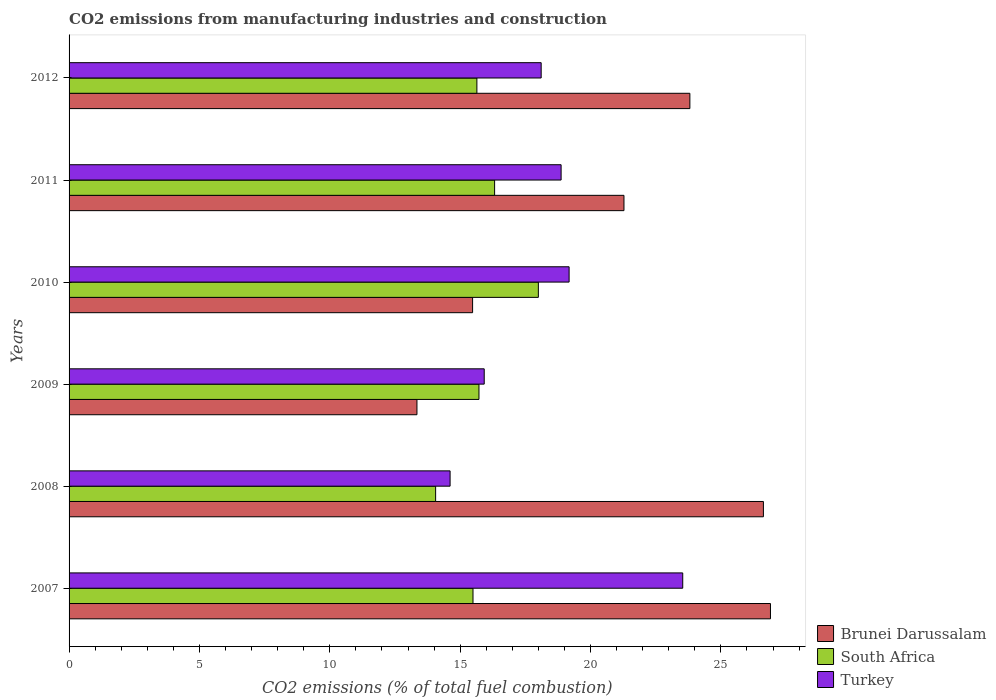How many different coloured bars are there?
Keep it short and to the point. 3. Are the number of bars per tick equal to the number of legend labels?
Keep it short and to the point. Yes. Are the number of bars on each tick of the Y-axis equal?
Give a very brief answer. Yes. How many bars are there on the 5th tick from the top?
Ensure brevity in your answer.  3. In how many cases, is the number of bars for a given year not equal to the number of legend labels?
Provide a short and direct response. 0. What is the amount of CO2 emitted in Brunei Darussalam in 2010?
Provide a succinct answer. 15.48. Across all years, what is the maximum amount of CO2 emitted in South Africa?
Provide a succinct answer. 18. Across all years, what is the minimum amount of CO2 emitted in Turkey?
Your answer should be compact. 14.61. In which year was the amount of CO2 emitted in South Africa minimum?
Your response must be concise. 2008. What is the total amount of CO2 emitted in Turkey in the graph?
Offer a very short reply. 110.23. What is the difference between the amount of CO2 emitted in Turkey in 2007 and that in 2011?
Your answer should be very brief. 4.66. What is the difference between the amount of CO2 emitted in South Africa in 2010 and the amount of CO2 emitted in Brunei Darussalam in 2012?
Offer a very short reply. -5.81. What is the average amount of CO2 emitted in South Africa per year?
Keep it short and to the point. 15.87. In the year 2012, what is the difference between the amount of CO2 emitted in Brunei Darussalam and amount of CO2 emitted in Turkey?
Ensure brevity in your answer.  5.7. What is the ratio of the amount of CO2 emitted in South Africa in 2007 to that in 2010?
Keep it short and to the point. 0.86. Is the amount of CO2 emitted in Brunei Darussalam in 2007 less than that in 2012?
Your answer should be compact. No. What is the difference between the highest and the second highest amount of CO2 emitted in South Africa?
Give a very brief answer. 1.68. What is the difference between the highest and the lowest amount of CO2 emitted in South Africa?
Your answer should be very brief. 3.94. In how many years, is the amount of CO2 emitted in South Africa greater than the average amount of CO2 emitted in South Africa taken over all years?
Your answer should be very brief. 2. Is the sum of the amount of CO2 emitted in Brunei Darussalam in 2010 and 2012 greater than the maximum amount of CO2 emitted in Turkey across all years?
Offer a very short reply. Yes. What does the 1st bar from the top in 2008 represents?
Keep it short and to the point. Turkey. How many bars are there?
Provide a short and direct response. 18. What is the difference between two consecutive major ticks on the X-axis?
Your answer should be compact. 5. Are the values on the major ticks of X-axis written in scientific E-notation?
Your answer should be very brief. No. Does the graph contain any zero values?
Offer a very short reply. No. How many legend labels are there?
Provide a short and direct response. 3. How are the legend labels stacked?
Your response must be concise. Vertical. What is the title of the graph?
Give a very brief answer. CO2 emissions from manufacturing industries and construction. Does "Brazil" appear as one of the legend labels in the graph?
Provide a short and direct response. No. What is the label or title of the X-axis?
Provide a succinct answer. CO2 emissions (% of total fuel combustion). What is the label or title of the Y-axis?
Your answer should be compact. Years. What is the CO2 emissions (% of total fuel combustion) in Brunei Darussalam in 2007?
Make the answer very short. 26.9. What is the CO2 emissions (% of total fuel combustion) in South Africa in 2007?
Keep it short and to the point. 15.49. What is the CO2 emissions (% of total fuel combustion) in Turkey in 2007?
Your response must be concise. 23.54. What is the CO2 emissions (% of total fuel combustion) of Brunei Darussalam in 2008?
Make the answer very short. 26.63. What is the CO2 emissions (% of total fuel combustion) of South Africa in 2008?
Your response must be concise. 14.06. What is the CO2 emissions (% of total fuel combustion) in Turkey in 2008?
Keep it short and to the point. 14.61. What is the CO2 emissions (% of total fuel combustion) in Brunei Darussalam in 2009?
Provide a succinct answer. 13.34. What is the CO2 emissions (% of total fuel combustion) of South Africa in 2009?
Offer a terse response. 15.72. What is the CO2 emissions (% of total fuel combustion) of Turkey in 2009?
Your answer should be very brief. 15.92. What is the CO2 emissions (% of total fuel combustion) in Brunei Darussalam in 2010?
Keep it short and to the point. 15.48. What is the CO2 emissions (% of total fuel combustion) of South Africa in 2010?
Keep it short and to the point. 18. What is the CO2 emissions (% of total fuel combustion) in Turkey in 2010?
Your response must be concise. 19.18. What is the CO2 emissions (% of total fuel combustion) in Brunei Darussalam in 2011?
Offer a very short reply. 21.28. What is the CO2 emissions (% of total fuel combustion) in South Africa in 2011?
Give a very brief answer. 16.32. What is the CO2 emissions (% of total fuel combustion) of Turkey in 2011?
Offer a terse response. 18.87. What is the CO2 emissions (% of total fuel combustion) in Brunei Darussalam in 2012?
Ensure brevity in your answer.  23.81. What is the CO2 emissions (% of total fuel combustion) in South Africa in 2012?
Your response must be concise. 15.64. What is the CO2 emissions (% of total fuel combustion) of Turkey in 2012?
Offer a very short reply. 18.11. Across all years, what is the maximum CO2 emissions (% of total fuel combustion) in Brunei Darussalam?
Provide a succinct answer. 26.9. Across all years, what is the maximum CO2 emissions (% of total fuel combustion) in South Africa?
Offer a very short reply. 18. Across all years, what is the maximum CO2 emissions (% of total fuel combustion) of Turkey?
Provide a short and direct response. 23.54. Across all years, what is the minimum CO2 emissions (% of total fuel combustion) of Brunei Darussalam?
Your answer should be very brief. 13.34. Across all years, what is the minimum CO2 emissions (% of total fuel combustion) in South Africa?
Provide a succinct answer. 14.06. Across all years, what is the minimum CO2 emissions (% of total fuel combustion) of Turkey?
Provide a succinct answer. 14.61. What is the total CO2 emissions (% of total fuel combustion) of Brunei Darussalam in the graph?
Provide a short and direct response. 127.44. What is the total CO2 emissions (% of total fuel combustion) of South Africa in the graph?
Ensure brevity in your answer.  95.23. What is the total CO2 emissions (% of total fuel combustion) of Turkey in the graph?
Give a very brief answer. 110.23. What is the difference between the CO2 emissions (% of total fuel combustion) in Brunei Darussalam in 2007 and that in 2008?
Make the answer very short. 0.27. What is the difference between the CO2 emissions (% of total fuel combustion) in South Africa in 2007 and that in 2008?
Ensure brevity in your answer.  1.43. What is the difference between the CO2 emissions (% of total fuel combustion) in Turkey in 2007 and that in 2008?
Offer a terse response. 8.92. What is the difference between the CO2 emissions (% of total fuel combustion) of Brunei Darussalam in 2007 and that in 2009?
Your answer should be very brief. 13.56. What is the difference between the CO2 emissions (% of total fuel combustion) of South Africa in 2007 and that in 2009?
Offer a terse response. -0.23. What is the difference between the CO2 emissions (% of total fuel combustion) of Turkey in 2007 and that in 2009?
Give a very brief answer. 7.61. What is the difference between the CO2 emissions (% of total fuel combustion) of Brunei Darussalam in 2007 and that in 2010?
Give a very brief answer. 11.42. What is the difference between the CO2 emissions (% of total fuel combustion) of South Africa in 2007 and that in 2010?
Provide a succinct answer. -2.51. What is the difference between the CO2 emissions (% of total fuel combustion) of Turkey in 2007 and that in 2010?
Your answer should be compact. 4.36. What is the difference between the CO2 emissions (% of total fuel combustion) of Brunei Darussalam in 2007 and that in 2011?
Your answer should be compact. 5.62. What is the difference between the CO2 emissions (% of total fuel combustion) of South Africa in 2007 and that in 2011?
Your answer should be very brief. -0.83. What is the difference between the CO2 emissions (% of total fuel combustion) of Turkey in 2007 and that in 2011?
Your answer should be very brief. 4.66. What is the difference between the CO2 emissions (% of total fuel combustion) in Brunei Darussalam in 2007 and that in 2012?
Provide a succinct answer. 3.09. What is the difference between the CO2 emissions (% of total fuel combustion) of South Africa in 2007 and that in 2012?
Provide a succinct answer. -0.15. What is the difference between the CO2 emissions (% of total fuel combustion) of Turkey in 2007 and that in 2012?
Give a very brief answer. 5.43. What is the difference between the CO2 emissions (% of total fuel combustion) of Brunei Darussalam in 2008 and that in 2009?
Your answer should be compact. 13.29. What is the difference between the CO2 emissions (% of total fuel combustion) in South Africa in 2008 and that in 2009?
Your answer should be compact. -1.66. What is the difference between the CO2 emissions (% of total fuel combustion) in Turkey in 2008 and that in 2009?
Provide a succinct answer. -1.31. What is the difference between the CO2 emissions (% of total fuel combustion) in Brunei Darussalam in 2008 and that in 2010?
Keep it short and to the point. 11.15. What is the difference between the CO2 emissions (% of total fuel combustion) of South Africa in 2008 and that in 2010?
Your response must be concise. -3.94. What is the difference between the CO2 emissions (% of total fuel combustion) in Turkey in 2008 and that in 2010?
Provide a short and direct response. -4.56. What is the difference between the CO2 emissions (% of total fuel combustion) in Brunei Darussalam in 2008 and that in 2011?
Your answer should be very brief. 5.35. What is the difference between the CO2 emissions (% of total fuel combustion) of South Africa in 2008 and that in 2011?
Keep it short and to the point. -2.26. What is the difference between the CO2 emissions (% of total fuel combustion) in Turkey in 2008 and that in 2011?
Provide a succinct answer. -4.26. What is the difference between the CO2 emissions (% of total fuel combustion) of Brunei Darussalam in 2008 and that in 2012?
Your answer should be compact. 2.82. What is the difference between the CO2 emissions (% of total fuel combustion) in South Africa in 2008 and that in 2012?
Your answer should be very brief. -1.58. What is the difference between the CO2 emissions (% of total fuel combustion) of Turkey in 2008 and that in 2012?
Offer a very short reply. -3.49. What is the difference between the CO2 emissions (% of total fuel combustion) of Brunei Darussalam in 2009 and that in 2010?
Make the answer very short. -2.13. What is the difference between the CO2 emissions (% of total fuel combustion) of South Africa in 2009 and that in 2010?
Your answer should be compact. -2.28. What is the difference between the CO2 emissions (% of total fuel combustion) in Turkey in 2009 and that in 2010?
Your response must be concise. -3.26. What is the difference between the CO2 emissions (% of total fuel combustion) of Brunei Darussalam in 2009 and that in 2011?
Your response must be concise. -7.94. What is the difference between the CO2 emissions (% of total fuel combustion) in South Africa in 2009 and that in 2011?
Give a very brief answer. -0.6. What is the difference between the CO2 emissions (% of total fuel combustion) of Turkey in 2009 and that in 2011?
Provide a short and direct response. -2.95. What is the difference between the CO2 emissions (% of total fuel combustion) in Brunei Darussalam in 2009 and that in 2012?
Ensure brevity in your answer.  -10.47. What is the difference between the CO2 emissions (% of total fuel combustion) in South Africa in 2009 and that in 2012?
Provide a succinct answer. 0.08. What is the difference between the CO2 emissions (% of total fuel combustion) of Turkey in 2009 and that in 2012?
Give a very brief answer. -2.18. What is the difference between the CO2 emissions (% of total fuel combustion) of Brunei Darussalam in 2010 and that in 2011?
Give a very brief answer. -5.81. What is the difference between the CO2 emissions (% of total fuel combustion) in South Africa in 2010 and that in 2011?
Your answer should be very brief. 1.68. What is the difference between the CO2 emissions (% of total fuel combustion) in Turkey in 2010 and that in 2011?
Ensure brevity in your answer.  0.31. What is the difference between the CO2 emissions (% of total fuel combustion) in Brunei Darussalam in 2010 and that in 2012?
Ensure brevity in your answer.  -8.33. What is the difference between the CO2 emissions (% of total fuel combustion) in South Africa in 2010 and that in 2012?
Ensure brevity in your answer.  2.36. What is the difference between the CO2 emissions (% of total fuel combustion) in Turkey in 2010 and that in 2012?
Provide a succinct answer. 1.07. What is the difference between the CO2 emissions (% of total fuel combustion) in Brunei Darussalam in 2011 and that in 2012?
Provide a succinct answer. -2.53. What is the difference between the CO2 emissions (% of total fuel combustion) in South Africa in 2011 and that in 2012?
Offer a very short reply. 0.68. What is the difference between the CO2 emissions (% of total fuel combustion) of Turkey in 2011 and that in 2012?
Your answer should be compact. 0.76. What is the difference between the CO2 emissions (% of total fuel combustion) in Brunei Darussalam in 2007 and the CO2 emissions (% of total fuel combustion) in South Africa in 2008?
Provide a short and direct response. 12.84. What is the difference between the CO2 emissions (% of total fuel combustion) of Brunei Darussalam in 2007 and the CO2 emissions (% of total fuel combustion) of Turkey in 2008?
Give a very brief answer. 12.29. What is the difference between the CO2 emissions (% of total fuel combustion) of South Africa in 2007 and the CO2 emissions (% of total fuel combustion) of Turkey in 2008?
Offer a very short reply. 0.88. What is the difference between the CO2 emissions (% of total fuel combustion) of Brunei Darussalam in 2007 and the CO2 emissions (% of total fuel combustion) of South Africa in 2009?
Make the answer very short. 11.18. What is the difference between the CO2 emissions (% of total fuel combustion) in Brunei Darussalam in 2007 and the CO2 emissions (% of total fuel combustion) in Turkey in 2009?
Keep it short and to the point. 10.98. What is the difference between the CO2 emissions (% of total fuel combustion) in South Africa in 2007 and the CO2 emissions (% of total fuel combustion) in Turkey in 2009?
Provide a succinct answer. -0.43. What is the difference between the CO2 emissions (% of total fuel combustion) of Brunei Darussalam in 2007 and the CO2 emissions (% of total fuel combustion) of South Africa in 2010?
Offer a terse response. 8.9. What is the difference between the CO2 emissions (% of total fuel combustion) in Brunei Darussalam in 2007 and the CO2 emissions (% of total fuel combustion) in Turkey in 2010?
Ensure brevity in your answer.  7.72. What is the difference between the CO2 emissions (% of total fuel combustion) in South Africa in 2007 and the CO2 emissions (% of total fuel combustion) in Turkey in 2010?
Your response must be concise. -3.69. What is the difference between the CO2 emissions (% of total fuel combustion) of Brunei Darussalam in 2007 and the CO2 emissions (% of total fuel combustion) of South Africa in 2011?
Provide a succinct answer. 10.58. What is the difference between the CO2 emissions (% of total fuel combustion) of Brunei Darussalam in 2007 and the CO2 emissions (% of total fuel combustion) of Turkey in 2011?
Provide a succinct answer. 8.03. What is the difference between the CO2 emissions (% of total fuel combustion) in South Africa in 2007 and the CO2 emissions (% of total fuel combustion) in Turkey in 2011?
Provide a succinct answer. -3.38. What is the difference between the CO2 emissions (% of total fuel combustion) of Brunei Darussalam in 2007 and the CO2 emissions (% of total fuel combustion) of South Africa in 2012?
Offer a terse response. 11.26. What is the difference between the CO2 emissions (% of total fuel combustion) of Brunei Darussalam in 2007 and the CO2 emissions (% of total fuel combustion) of Turkey in 2012?
Your answer should be compact. 8.79. What is the difference between the CO2 emissions (% of total fuel combustion) in South Africa in 2007 and the CO2 emissions (% of total fuel combustion) in Turkey in 2012?
Your answer should be very brief. -2.61. What is the difference between the CO2 emissions (% of total fuel combustion) in Brunei Darussalam in 2008 and the CO2 emissions (% of total fuel combustion) in South Africa in 2009?
Provide a succinct answer. 10.91. What is the difference between the CO2 emissions (% of total fuel combustion) in Brunei Darussalam in 2008 and the CO2 emissions (% of total fuel combustion) in Turkey in 2009?
Provide a short and direct response. 10.71. What is the difference between the CO2 emissions (% of total fuel combustion) of South Africa in 2008 and the CO2 emissions (% of total fuel combustion) of Turkey in 2009?
Provide a succinct answer. -1.86. What is the difference between the CO2 emissions (% of total fuel combustion) of Brunei Darussalam in 2008 and the CO2 emissions (% of total fuel combustion) of South Africa in 2010?
Offer a very short reply. 8.63. What is the difference between the CO2 emissions (% of total fuel combustion) in Brunei Darussalam in 2008 and the CO2 emissions (% of total fuel combustion) in Turkey in 2010?
Make the answer very short. 7.45. What is the difference between the CO2 emissions (% of total fuel combustion) in South Africa in 2008 and the CO2 emissions (% of total fuel combustion) in Turkey in 2010?
Your response must be concise. -5.12. What is the difference between the CO2 emissions (% of total fuel combustion) of Brunei Darussalam in 2008 and the CO2 emissions (% of total fuel combustion) of South Africa in 2011?
Offer a terse response. 10.31. What is the difference between the CO2 emissions (% of total fuel combustion) of Brunei Darussalam in 2008 and the CO2 emissions (% of total fuel combustion) of Turkey in 2011?
Your answer should be very brief. 7.76. What is the difference between the CO2 emissions (% of total fuel combustion) of South Africa in 2008 and the CO2 emissions (% of total fuel combustion) of Turkey in 2011?
Provide a short and direct response. -4.81. What is the difference between the CO2 emissions (% of total fuel combustion) in Brunei Darussalam in 2008 and the CO2 emissions (% of total fuel combustion) in South Africa in 2012?
Offer a terse response. 10.99. What is the difference between the CO2 emissions (% of total fuel combustion) of Brunei Darussalam in 2008 and the CO2 emissions (% of total fuel combustion) of Turkey in 2012?
Make the answer very short. 8.52. What is the difference between the CO2 emissions (% of total fuel combustion) in South Africa in 2008 and the CO2 emissions (% of total fuel combustion) in Turkey in 2012?
Provide a short and direct response. -4.05. What is the difference between the CO2 emissions (% of total fuel combustion) of Brunei Darussalam in 2009 and the CO2 emissions (% of total fuel combustion) of South Africa in 2010?
Offer a very short reply. -4.66. What is the difference between the CO2 emissions (% of total fuel combustion) in Brunei Darussalam in 2009 and the CO2 emissions (% of total fuel combustion) in Turkey in 2010?
Your answer should be compact. -5.84. What is the difference between the CO2 emissions (% of total fuel combustion) of South Africa in 2009 and the CO2 emissions (% of total fuel combustion) of Turkey in 2010?
Your answer should be compact. -3.46. What is the difference between the CO2 emissions (% of total fuel combustion) of Brunei Darussalam in 2009 and the CO2 emissions (% of total fuel combustion) of South Africa in 2011?
Your answer should be compact. -2.98. What is the difference between the CO2 emissions (% of total fuel combustion) of Brunei Darussalam in 2009 and the CO2 emissions (% of total fuel combustion) of Turkey in 2011?
Your answer should be compact. -5.53. What is the difference between the CO2 emissions (% of total fuel combustion) of South Africa in 2009 and the CO2 emissions (% of total fuel combustion) of Turkey in 2011?
Make the answer very short. -3.15. What is the difference between the CO2 emissions (% of total fuel combustion) of Brunei Darussalam in 2009 and the CO2 emissions (% of total fuel combustion) of South Africa in 2012?
Provide a short and direct response. -2.3. What is the difference between the CO2 emissions (% of total fuel combustion) of Brunei Darussalam in 2009 and the CO2 emissions (% of total fuel combustion) of Turkey in 2012?
Ensure brevity in your answer.  -4.76. What is the difference between the CO2 emissions (% of total fuel combustion) in South Africa in 2009 and the CO2 emissions (% of total fuel combustion) in Turkey in 2012?
Keep it short and to the point. -2.39. What is the difference between the CO2 emissions (% of total fuel combustion) in Brunei Darussalam in 2010 and the CO2 emissions (% of total fuel combustion) in South Africa in 2011?
Provide a succinct answer. -0.84. What is the difference between the CO2 emissions (% of total fuel combustion) of Brunei Darussalam in 2010 and the CO2 emissions (% of total fuel combustion) of Turkey in 2011?
Ensure brevity in your answer.  -3.39. What is the difference between the CO2 emissions (% of total fuel combustion) of South Africa in 2010 and the CO2 emissions (% of total fuel combustion) of Turkey in 2011?
Offer a terse response. -0.87. What is the difference between the CO2 emissions (% of total fuel combustion) of Brunei Darussalam in 2010 and the CO2 emissions (% of total fuel combustion) of South Africa in 2012?
Make the answer very short. -0.17. What is the difference between the CO2 emissions (% of total fuel combustion) in Brunei Darussalam in 2010 and the CO2 emissions (% of total fuel combustion) in Turkey in 2012?
Offer a terse response. -2.63. What is the difference between the CO2 emissions (% of total fuel combustion) of South Africa in 2010 and the CO2 emissions (% of total fuel combustion) of Turkey in 2012?
Give a very brief answer. -0.11. What is the difference between the CO2 emissions (% of total fuel combustion) in Brunei Darussalam in 2011 and the CO2 emissions (% of total fuel combustion) in South Africa in 2012?
Offer a terse response. 5.64. What is the difference between the CO2 emissions (% of total fuel combustion) in Brunei Darussalam in 2011 and the CO2 emissions (% of total fuel combustion) in Turkey in 2012?
Offer a terse response. 3.18. What is the difference between the CO2 emissions (% of total fuel combustion) of South Africa in 2011 and the CO2 emissions (% of total fuel combustion) of Turkey in 2012?
Your answer should be compact. -1.79. What is the average CO2 emissions (% of total fuel combustion) in Brunei Darussalam per year?
Give a very brief answer. 21.24. What is the average CO2 emissions (% of total fuel combustion) in South Africa per year?
Provide a succinct answer. 15.87. What is the average CO2 emissions (% of total fuel combustion) of Turkey per year?
Your answer should be compact. 18.37. In the year 2007, what is the difference between the CO2 emissions (% of total fuel combustion) in Brunei Darussalam and CO2 emissions (% of total fuel combustion) in South Africa?
Offer a very short reply. 11.41. In the year 2007, what is the difference between the CO2 emissions (% of total fuel combustion) of Brunei Darussalam and CO2 emissions (% of total fuel combustion) of Turkey?
Offer a terse response. 3.36. In the year 2007, what is the difference between the CO2 emissions (% of total fuel combustion) in South Africa and CO2 emissions (% of total fuel combustion) in Turkey?
Your response must be concise. -8.04. In the year 2008, what is the difference between the CO2 emissions (% of total fuel combustion) of Brunei Darussalam and CO2 emissions (% of total fuel combustion) of South Africa?
Provide a succinct answer. 12.57. In the year 2008, what is the difference between the CO2 emissions (% of total fuel combustion) of Brunei Darussalam and CO2 emissions (% of total fuel combustion) of Turkey?
Offer a terse response. 12.02. In the year 2008, what is the difference between the CO2 emissions (% of total fuel combustion) in South Africa and CO2 emissions (% of total fuel combustion) in Turkey?
Offer a very short reply. -0.55. In the year 2009, what is the difference between the CO2 emissions (% of total fuel combustion) of Brunei Darussalam and CO2 emissions (% of total fuel combustion) of South Africa?
Keep it short and to the point. -2.38. In the year 2009, what is the difference between the CO2 emissions (% of total fuel combustion) in Brunei Darussalam and CO2 emissions (% of total fuel combustion) in Turkey?
Provide a short and direct response. -2.58. In the year 2009, what is the difference between the CO2 emissions (% of total fuel combustion) in South Africa and CO2 emissions (% of total fuel combustion) in Turkey?
Ensure brevity in your answer.  -0.2. In the year 2010, what is the difference between the CO2 emissions (% of total fuel combustion) of Brunei Darussalam and CO2 emissions (% of total fuel combustion) of South Africa?
Make the answer very short. -2.52. In the year 2010, what is the difference between the CO2 emissions (% of total fuel combustion) in Brunei Darussalam and CO2 emissions (% of total fuel combustion) in Turkey?
Your answer should be very brief. -3.7. In the year 2010, what is the difference between the CO2 emissions (% of total fuel combustion) of South Africa and CO2 emissions (% of total fuel combustion) of Turkey?
Provide a succinct answer. -1.18. In the year 2011, what is the difference between the CO2 emissions (% of total fuel combustion) of Brunei Darussalam and CO2 emissions (% of total fuel combustion) of South Africa?
Provide a succinct answer. 4.96. In the year 2011, what is the difference between the CO2 emissions (% of total fuel combustion) of Brunei Darussalam and CO2 emissions (% of total fuel combustion) of Turkey?
Offer a very short reply. 2.41. In the year 2011, what is the difference between the CO2 emissions (% of total fuel combustion) in South Africa and CO2 emissions (% of total fuel combustion) in Turkey?
Keep it short and to the point. -2.55. In the year 2012, what is the difference between the CO2 emissions (% of total fuel combustion) in Brunei Darussalam and CO2 emissions (% of total fuel combustion) in South Africa?
Provide a short and direct response. 8.17. In the year 2012, what is the difference between the CO2 emissions (% of total fuel combustion) in Brunei Darussalam and CO2 emissions (% of total fuel combustion) in Turkey?
Offer a very short reply. 5.7. In the year 2012, what is the difference between the CO2 emissions (% of total fuel combustion) of South Africa and CO2 emissions (% of total fuel combustion) of Turkey?
Offer a terse response. -2.47. What is the ratio of the CO2 emissions (% of total fuel combustion) of Brunei Darussalam in 2007 to that in 2008?
Your response must be concise. 1.01. What is the ratio of the CO2 emissions (% of total fuel combustion) in South Africa in 2007 to that in 2008?
Give a very brief answer. 1.1. What is the ratio of the CO2 emissions (% of total fuel combustion) of Turkey in 2007 to that in 2008?
Ensure brevity in your answer.  1.61. What is the ratio of the CO2 emissions (% of total fuel combustion) of Brunei Darussalam in 2007 to that in 2009?
Make the answer very short. 2.02. What is the ratio of the CO2 emissions (% of total fuel combustion) of South Africa in 2007 to that in 2009?
Provide a short and direct response. 0.99. What is the ratio of the CO2 emissions (% of total fuel combustion) of Turkey in 2007 to that in 2009?
Make the answer very short. 1.48. What is the ratio of the CO2 emissions (% of total fuel combustion) of Brunei Darussalam in 2007 to that in 2010?
Offer a very short reply. 1.74. What is the ratio of the CO2 emissions (% of total fuel combustion) of South Africa in 2007 to that in 2010?
Your answer should be very brief. 0.86. What is the ratio of the CO2 emissions (% of total fuel combustion) of Turkey in 2007 to that in 2010?
Make the answer very short. 1.23. What is the ratio of the CO2 emissions (% of total fuel combustion) in Brunei Darussalam in 2007 to that in 2011?
Ensure brevity in your answer.  1.26. What is the ratio of the CO2 emissions (% of total fuel combustion) of South Africa in 2007 to that in 2011?
Make the answer very short. 0.95. What is the ratio of the CO2 emissions (% of total fuel combustion) of Turkey in 2007 to that in 2011?
Keep it short and to the point. 1.25. What is the ratio of the CO2 emissions (% of total fuel combustion) in Brunei Darussalam in 2007 to that in 2012?
Ensure brevity in your answer.  1.13. What is the ratio of the CO2 emissions (% of total fuel combustion) of South Africa in 2007 to that in 2012?
Your answer should be compact. 0.99. What is the ratio of the CO2 emissions (% of total fuel combustion) in Turkey in 2007 to that in 2012?
Your response must be concise. 1.3. What is the ratio of the CO2 emissions (% of total fuel combustion) of Brunei Darussalam in 2008 to that in 2009?
Your answer should be very brief. 2. What is the ratio of the CO2 emissions (% of total fuel combustion) in South Africa in 2008 to that in 2009?
Ensure brevity in your answer.  0.89. What is the ratio of the CO2 emissions (% of total fuel combustion) in Turkey in 2008 to that in 2009?
Your response must be concise. 0.92. What is the ratio of the CO2 emissions (% of total fuel combustion) in Brunei Darussalam in 2008 to that in 2010?
Provide a succinct answer. 1.72. What is the ratio of the CO2 emissions (% of total fuel combustion) of South Africa in 2008 to that in 2010?
Offer a very short reply. 0.78. What is the ratio of the CO2 emissions (% of total fuel combustion) of Turkey in 2008 to that in 2010?
Give a very brief answer. 0.76. What is the ratio of the CO2 emissions (% of total fuel combustion) of Brunei Darussalam in 2008 to that in 2011?
Your answer should be compact. 1.25. What is the ratio of the CO2 emissions (% of total fuel combustion) in South Africa in 2008 to that in 2011?
Make the answer very short. 0.86. What is the ratio of the CO2 emissions (% of total fuel combustion) of Turkey in 2008 to that in 2011?
Give a very brief answer. 0.77. What is the ratio of the CO2 emissions (% of total fuel combustion) of Brunei Darussalam in 2008 to that in 2012?
Your answer should be very brief. 1.12. What is the ratio of the CO2 emissions (% of total fuel combustion) of South Africa in 2008 to that in 2012?
Your answer should be very brief. 0.9. What is the ratio of the CO2 emissions (% of total fuel combustion) of Turkey in 2008 to that in 2012?
Ensure brevity in your answer.  0.81. What is the ratio of the CO2 emissions (% of total fuel combustion) in Brunei Darussalam in 2009 to that in 2010?
Your response must be concise. 0.86. What is the ratio of the CO2 emissions (% of total fuel combustion) of South Africa in 2009 to that in 2010?
Provide a succinct answer. 0.87. What is the ratio of the CO2 emissions (% of total fuel combustion) in Turkey in 2009 to that in 2010?
Provide a short and direct response. 0.83. What is the ratio of the CO2 emissions (% of total fuel combustion) in Brunei Darussalam in 2009 to that in 2011?
Keep it short and to the point. 0.63. What is the ratio of the CO2 emissions (% of total fuel combustion) in South Africa in 2009 to that in 2011?
Your response must be concise. 0.96. What is the ratio of the CO2 emissions (% of total fuel combustion) in Turkey in 2009 to that in 2011?
Ensure brevity in your answer.  0.84. What is the ratio of the CO2 emissions (% of total fuel combustion) in Brunei Darussalam in 2009 to that in 2012?
Your answer should be very brief. 0.56. What is the ratio of the CO2 emissions (% of total fuel combustion) in Turkey in 2009 to that in 2012?
Provide a short and direct response. 0.88. What is the ratio of the CO2 emissions (% of total fuel combustion) in Brunei Darussalam in 2010 to that in 2011?
Your response must be concise. 0.73. What is the ratio of the CO2 emissions (% of total fuel combustion) in South Africa in 2010 to that in 2011?
Your response must be concise. 1.1. What is the ratio of the CO2 emissions (% of total fuel combustion) of Turkey in 2010 to that in 2011?
Make the answer very short. 1.02. What is the ratio of the CO2 emissions (% of total fuel combustion) in Brunei Darussalam in 2010 to that in 2012?
Give a very brief answer. 0.65. What is the ratio of the CO2 emissions (% of total fuel combustion) in South Africa in 2010 to that in 2012?
Make the answer very short. 1.15. What is the ratio of the CO2 emissions (% of total fuel combustion) of Turkey in 2010 to that in 2012?
Make the answer very short. 1.06. What is the ratio of the CO2 emissions (% of total fuel combustion) of Brunei Darussalam in 2011 to that in 2012?
Give a very brief answer. 0.89. What is the ratio of the CO2 emissions (% of total fuel combustion) in South Africa in 2011 to that in 2012?
Offer a very short reply. 1.04. What is the ratio of the CO2 emissions (% of total fuel combustion) in Turkey in 2011 to that in 2012?
Your answer should be compact. 1.04. What is the difference between the highest and the second highest CO2 emissions (% of total fuel combustion) in Brunei Darussalam?
Offer a very short reply. 0.27. What is the difference between the highest and the second highest CO2 emissions (% of total fuel combustion) of South Africa?
Offer a terse response. 1.68. What is the difference between the highest and the second highest CO2 emissions (% of total fuel combustion) of Turkey?
Offer a very short reply. 4.36. What is the difference between the highest and the lowest CO2 emissions (% of total fuel combustion) in Brunei Darussalam?
Make the answer very short. 13.56. What is the difference between the highest and the lowest CO2 emissions (% of total fuel combustion) in South Africa?
Give a very brief answer. 3.94. What is the difference between the highest and the lowest CO2 emissions (% of total fuel combustion) in Turkey?
Your answer should be compact. 8.92. 